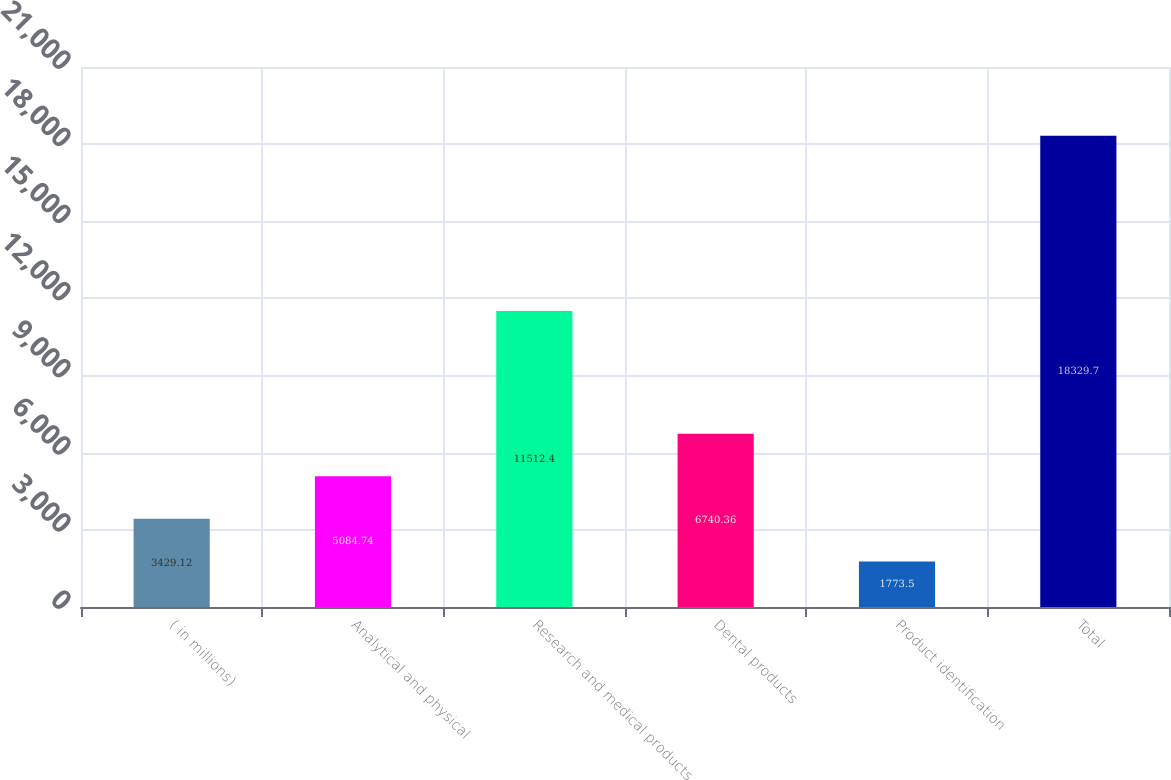Convert chart. <chart><loc_0><loc_0><loc_500><loc_500><bar_chart><fcel>( in millions)<fcel>Analytical and physical<fcel>Research and medical products<fcel>Dental products<fcel>Product identification<fcel>Total<nl><fcel>3429.12<fcel>5084.74<fcel>11512.4<fcel>6740.36<fcel>1773.5<fcel>18329.7<nl></chart> 